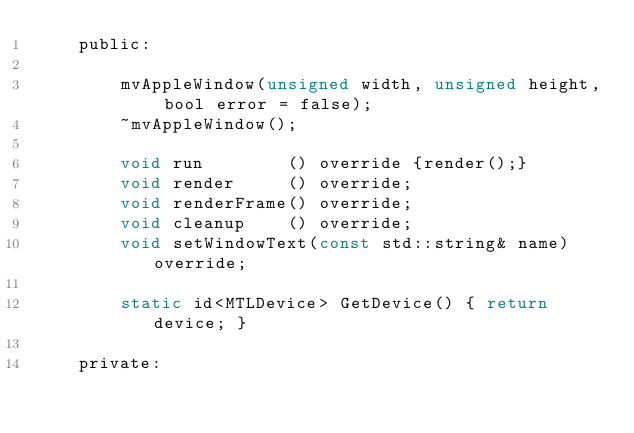Convert code to text. <code><loc_0><loc_0><loc_500><loc_500><_C_>    public:

        mvAppleWindow(unsigned width, unsigned height, bool error = false);
        ~mvAppleWindow();

        void run        () override {render();}
        void render     () override;
        void renderFrame() override;
        void cleanup    () override;
        void setWindowText(const std::string& name) override;

        static id<MTLDevice> GetDevice() { return device; }

    private:
</code> 